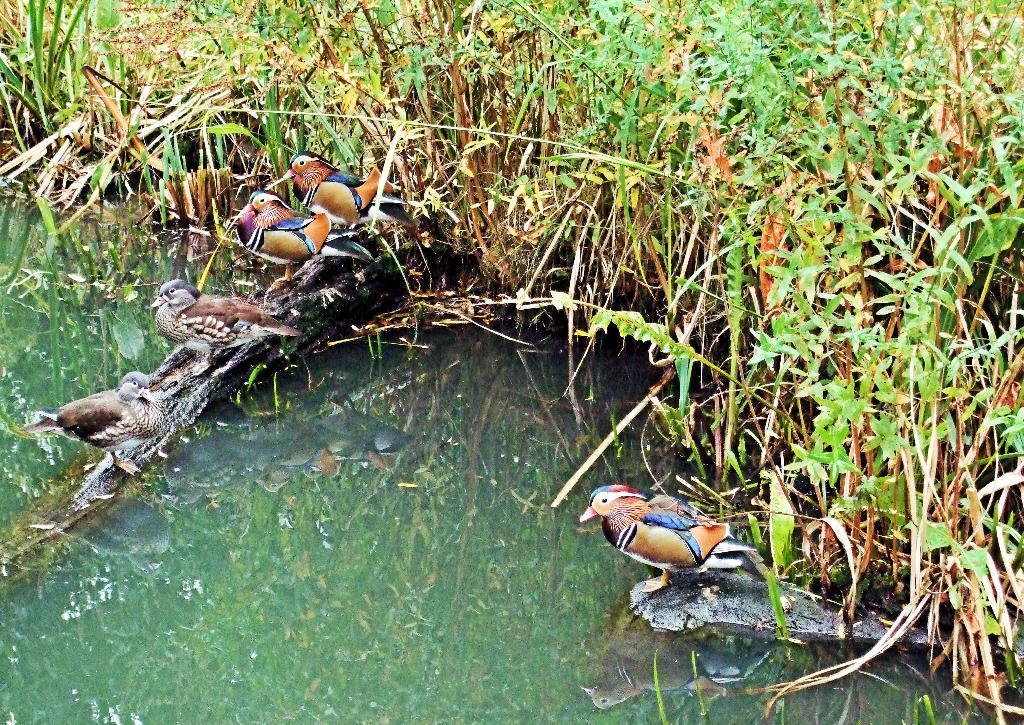How would you summarize this image in a sentence or two? In this image, there are birds and plants. I can see the reflection of birds and plants on the water. 